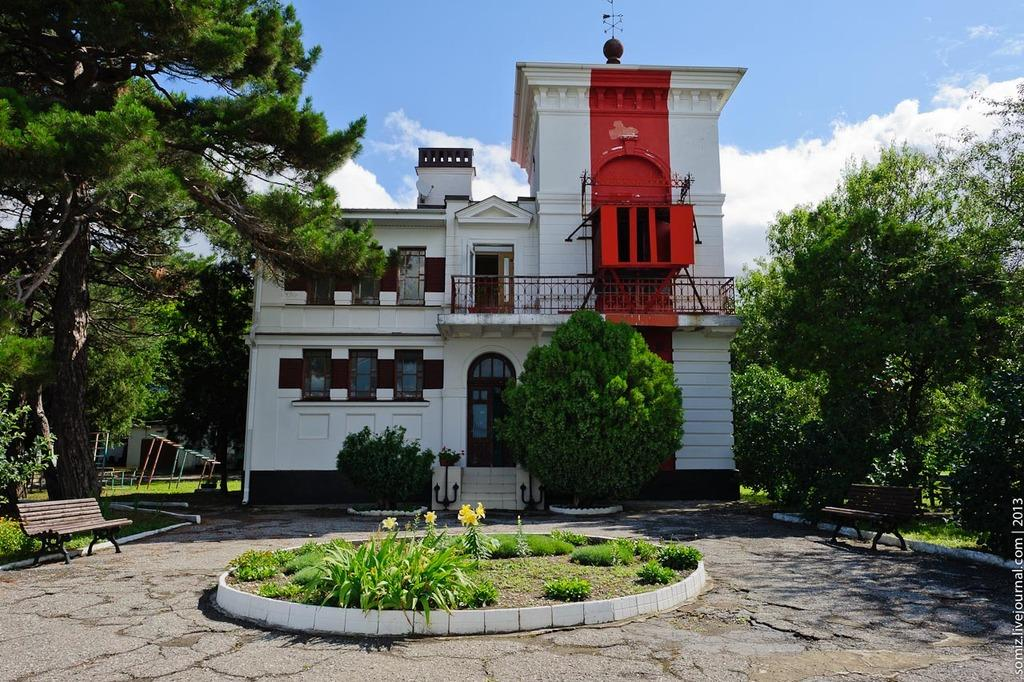What type of structure is in the image? There is a building in the image. What feature can be seen on the building? The building has windows. What is the boundary in the image? There is a fence in the image. What type of vegetation is present in the image? Grass is present in the image. What type of seating is in the image? There is a bench in the image. What type of natural elements are visible in the image? Trees are visible in the image. What type of mark is on the image? There is a water mark in the image. What is the condition of the sky in the image? The sky is cloudy in the image. What type of yarn is being used to develop the building in the image? There is no yarn being used to develop the building in the image, and yarn is not a material used in construction. 